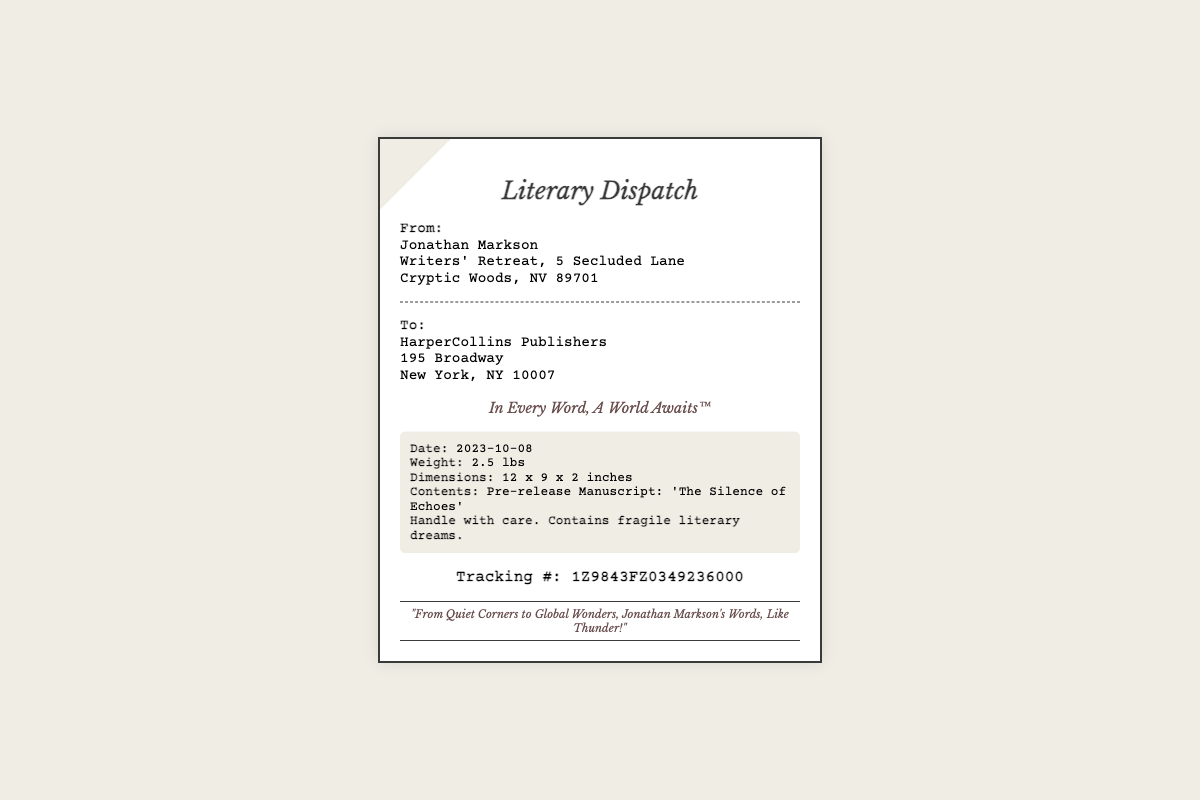What is the sender's name? The sender's name is listed at the top of the label, indicating who sent the package.
Answer: Jonathan Markson What is the recipient's name? The recipient's name is provided in the address section, identifying the intended receiver of the manuscript.
Answer: HarperCollins Publishers What is the date of shipment? The date of shipment is mentioned in the details section of the label, indicating when the package was dispatched.
Answer: 2023-10-08 What are the contents of the shipment? The contents section specifies what is contained in the package being sent.
Answer: Pre-release Manuscript: 'The Silence of Echoes' What is the weight of the package? The weight of the shipment is included in the details section, indicating how heavy the package is.
Answer: 2.5 lbs What slogan is featured on the label? The slogan provides a catchy phrase associated with the manuscript and is prominently displayed on the label.
Answer: In Every Word, A World Awaits™ What is the tracking number? The tracking number allows for the shipment to be tracked during its transit and is provided at the bottom of the label.
Answer: 1Z9843FZ0349236000 What is the handling instruction? The handling instruction indicates how the package should be treated during shipping.
Answer: Handle with care. Contains fragile literary dreams What is the dimension of the package? The dimensions of the package are given in the details section, specifying its size.
Answer: 12 x 9 x 2 inches 